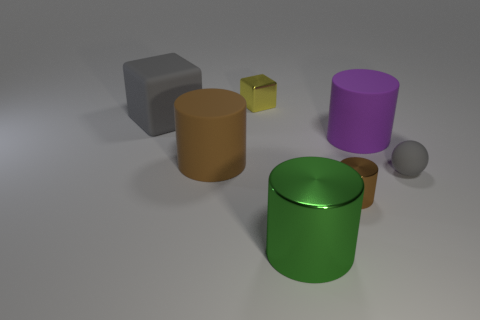How many brown cylinders must be subtracted to get 1 brown cylinders? 1 Subtract all cylinders. How many objects are left? 3 Add 1 large cyan cylinders. How many objects exist? 8 Subtract all purple cylinders. How many cylinders are left? 3 Subtract all brown metallic cylinders. How many cylinders are left? 3 Subtract 0 red cylinders. How many objects are left? 7 Subtract 1 balls. How many balls are left? 0 Subtract all cyan cylinders. Subtract all blue spheres. How many cylinders are left? 4 Subtract all blue balls. How many brown cylinders are left? 2 Subtract all yellow objects. Subtract all purple cylinders. How many objects are left? 5 